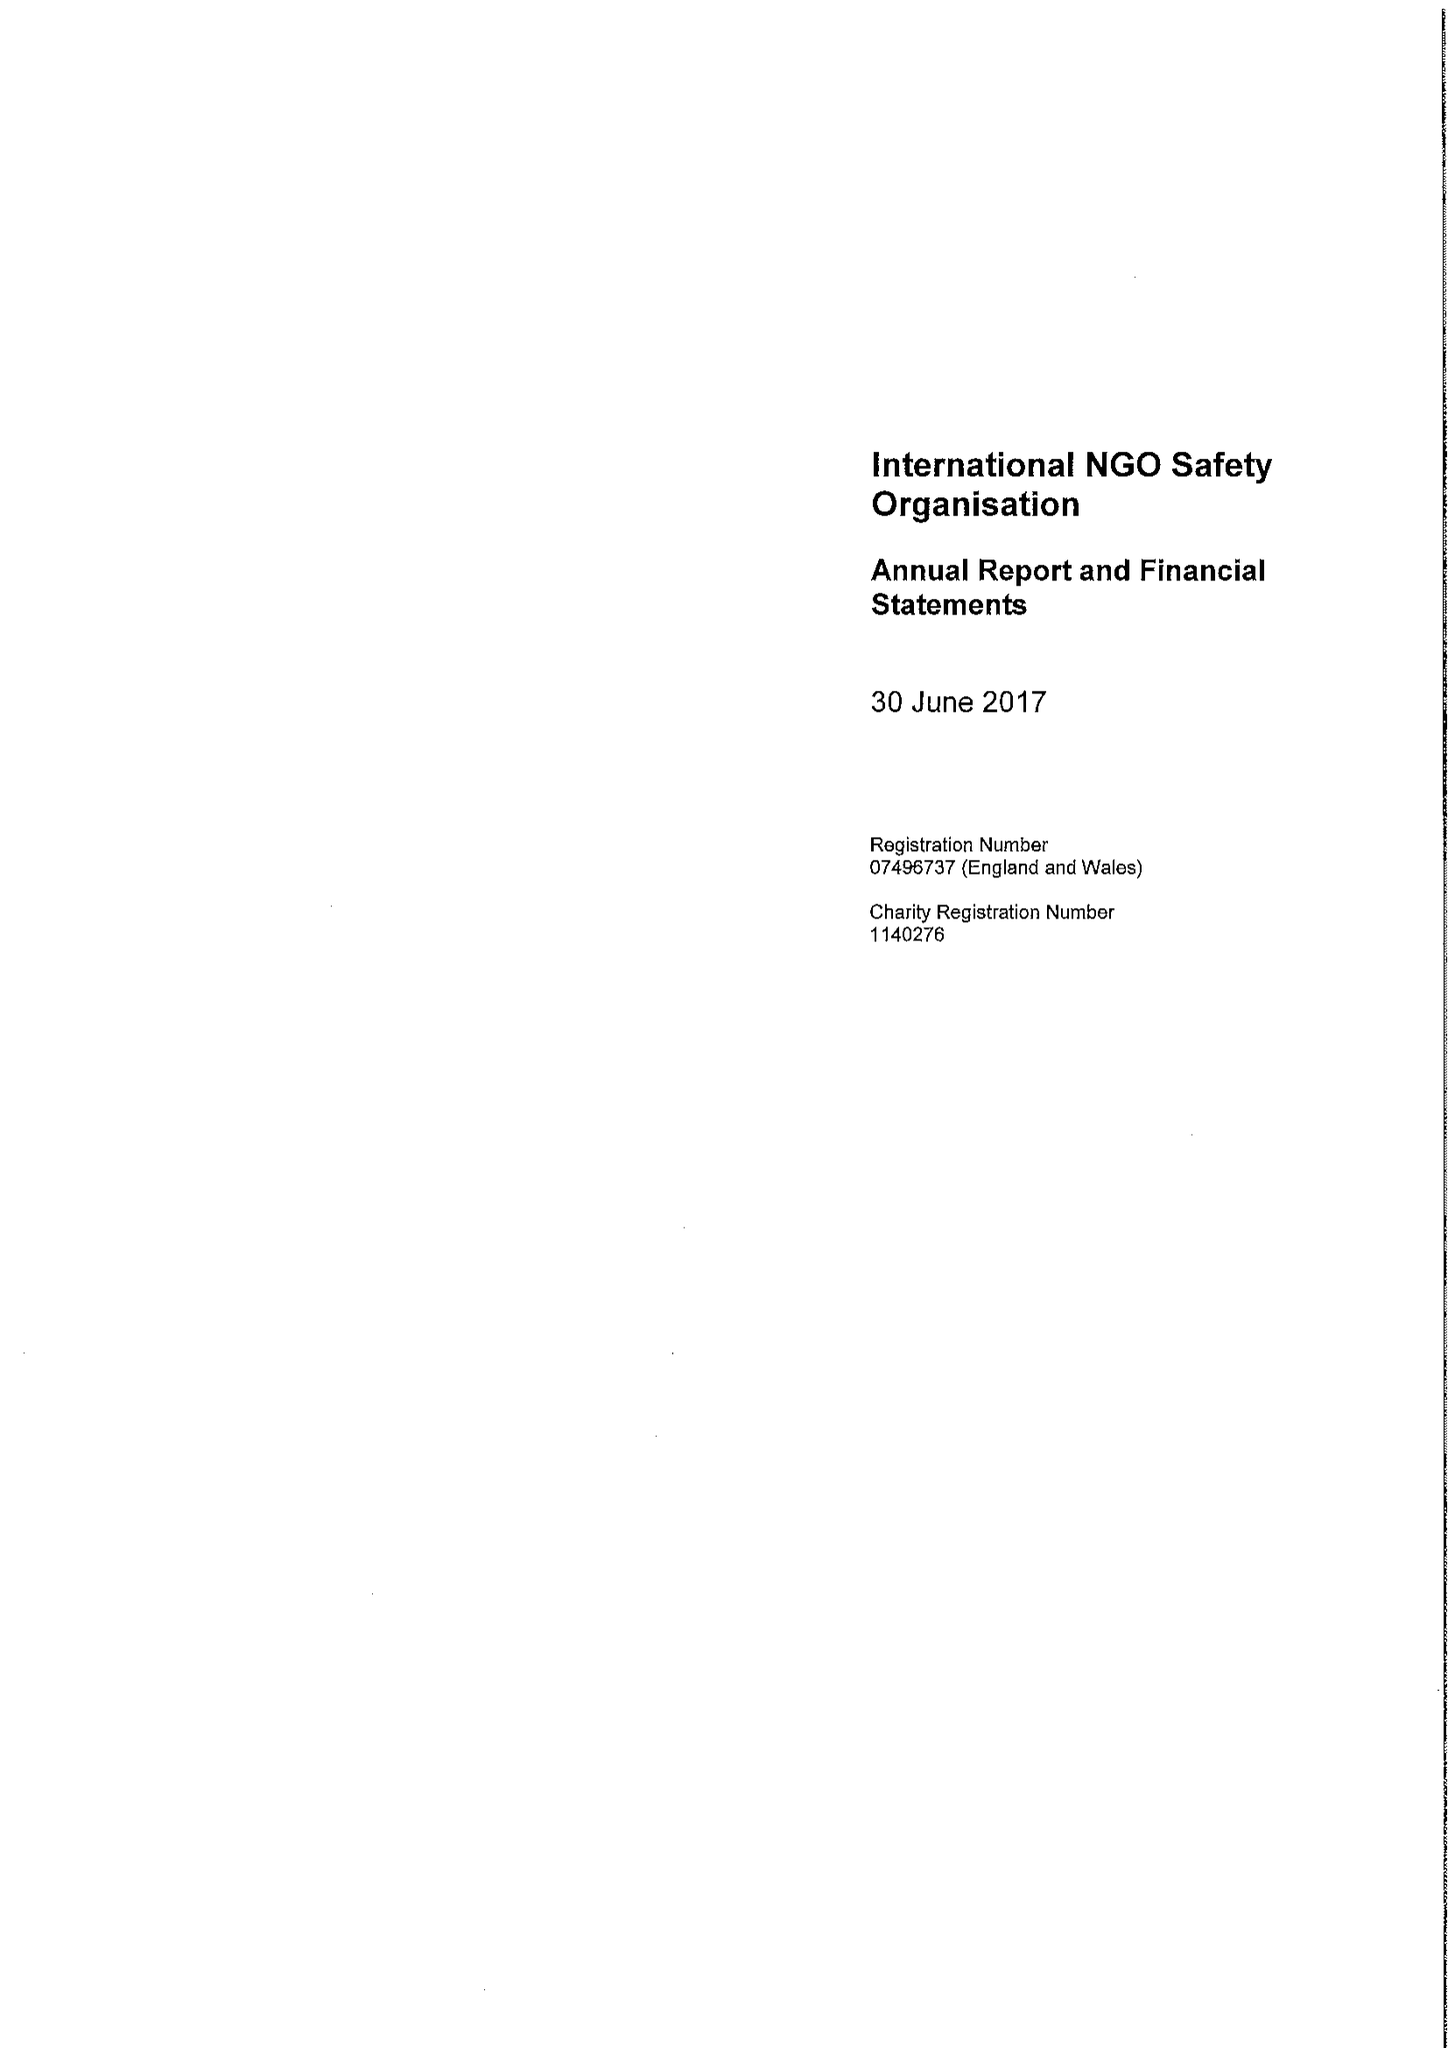What is the value for the report_date?
Answer the question using a single word or phrase. 2017-06-30 